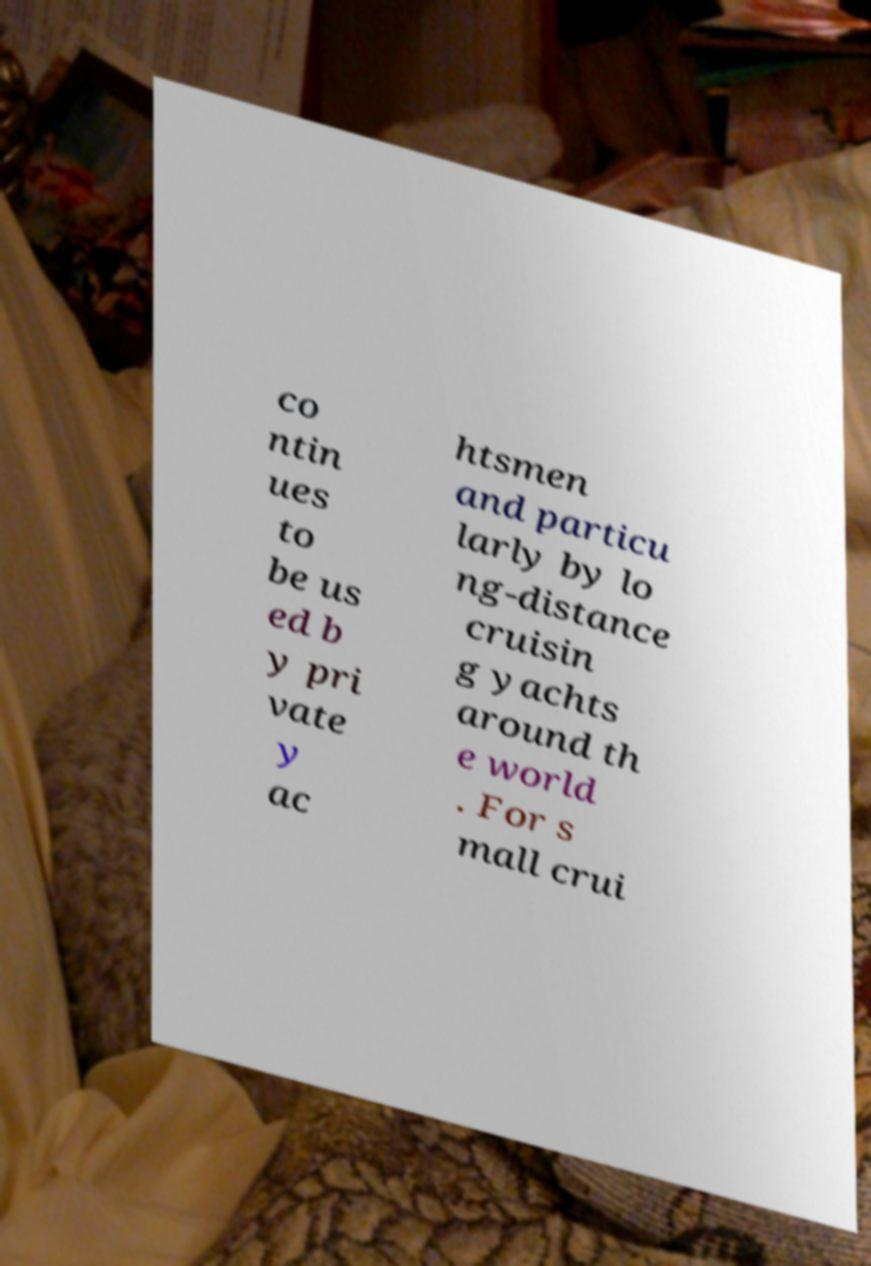Can you accurately transcribe the text from the provided image for me? co ntin ues to be us ed b y pri vate y ac htsmen and particu larly by lo ng-distance cruisin g yachts around th e world . For s mall crui 